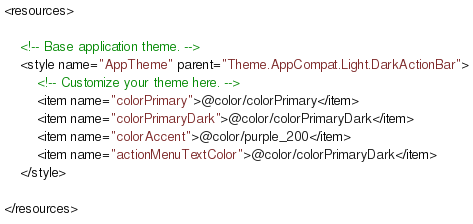<code> <loc_0><loc_0><loc_500><loc_500><_XML_><resources>

    <!-- Base application theme. -->
    <style name="AppTheme" parent="Theme.AppCompat.Light.DarkActionBar">
        <!-- Customize your theme here. -->
        <item name="colorPrimary">@color/colorPrimary</item>
        <item name="colorPrimaryDark">@color/colorPrimaryDark</item>
        <item name="colorAccent">@color/purple_200</item>
        <item name="actionMenuTextColor">@color/colorPrimaryDark</item>
    </style>

</resources>
</code> 